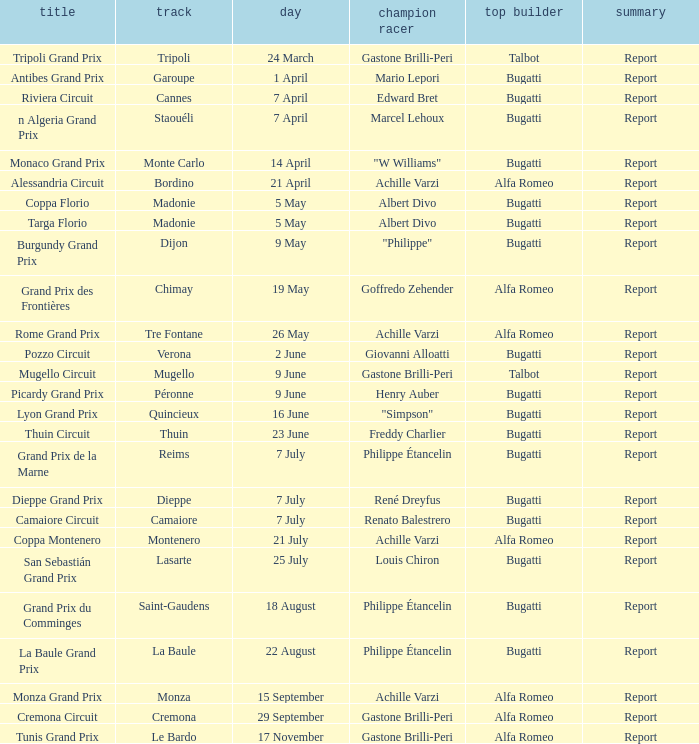What Circuit has a Winning constructor of bugatti, and a Winning driver of edward bret? Cannes. 